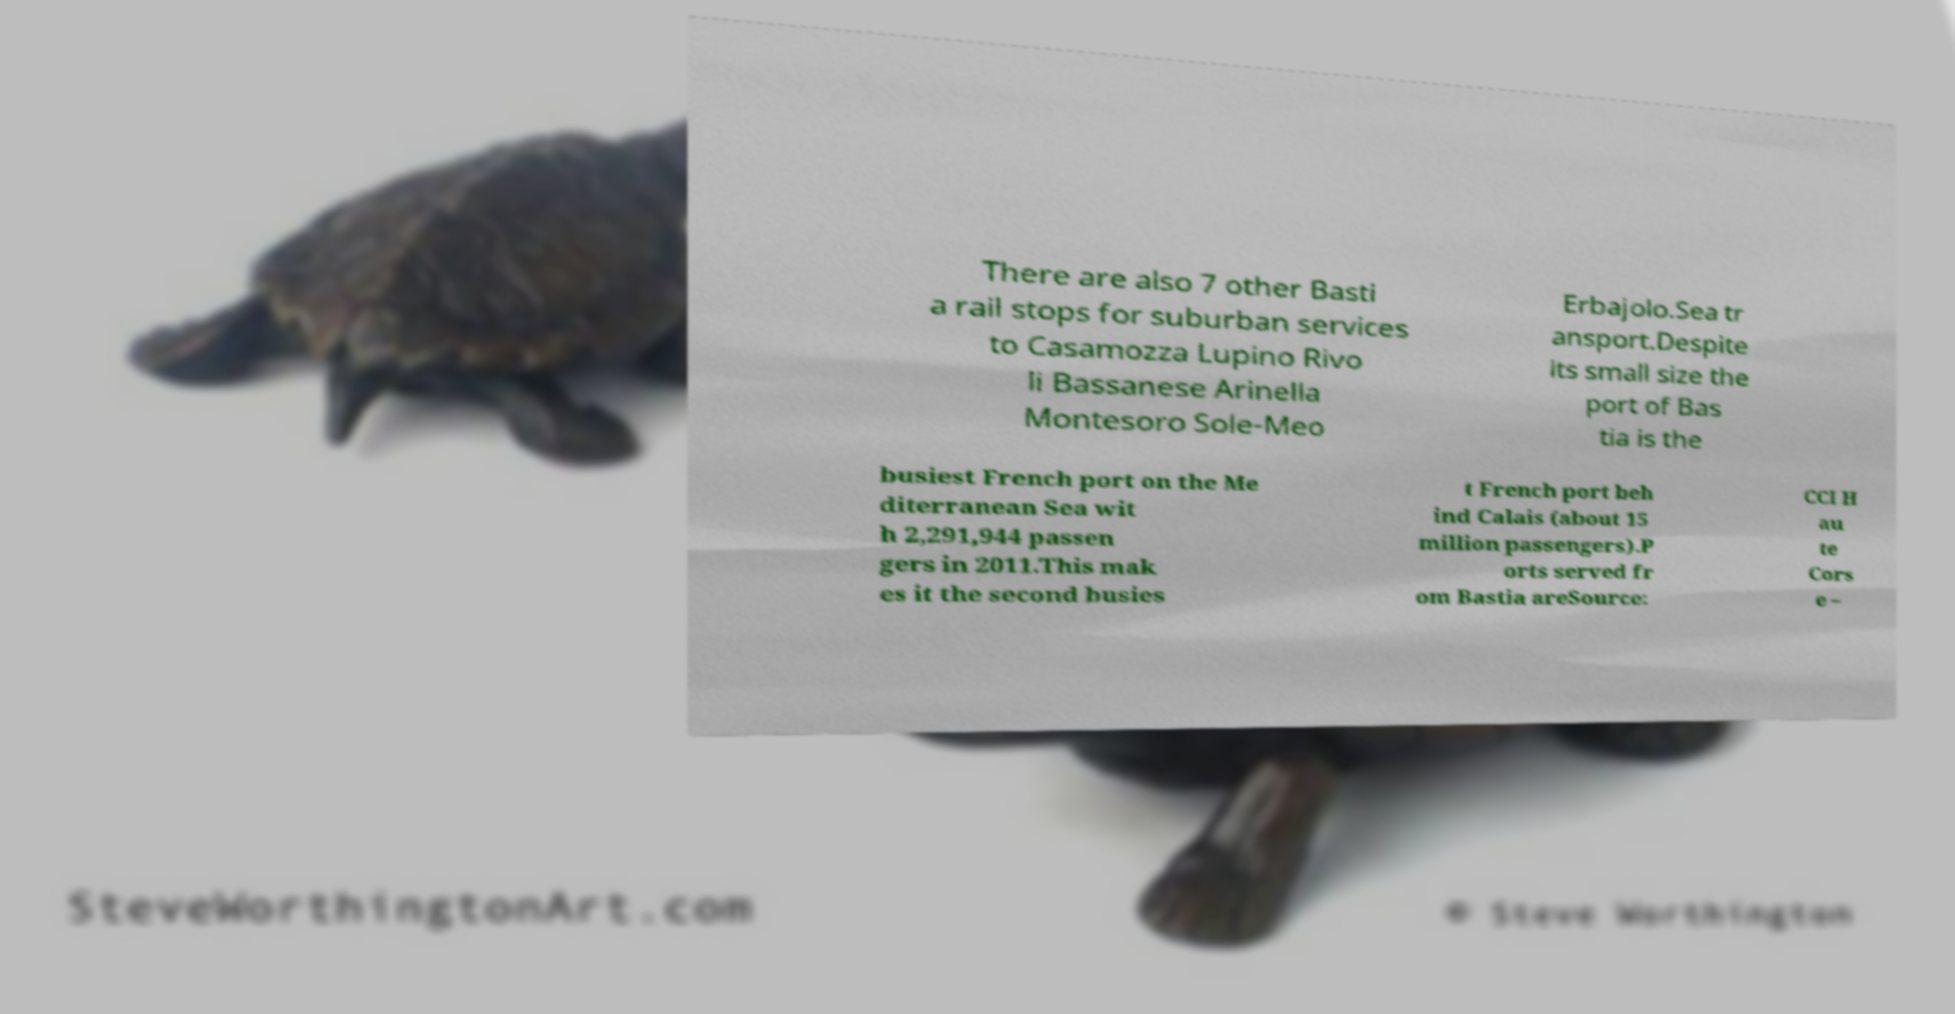There's text embedded in this image that I need extracted. Can you transcribe it verbatim? There are also 7 other Basti a rail stops for suburban services to Casamozza Lupino Rivo li Bassanese Arinella Montesoro Sole-Meo Erbajolo.Sea tr ansport.Despite its small size the port of Bas tia is the busiest French port on the Me diterranean Sea wit h 2,291,944 passen gers in 2011.This mak es it the second busies t French port beh ind Calais (about 15 million passengers).P orts served fr om Bastia areSource: CCI H au te Cors e – 